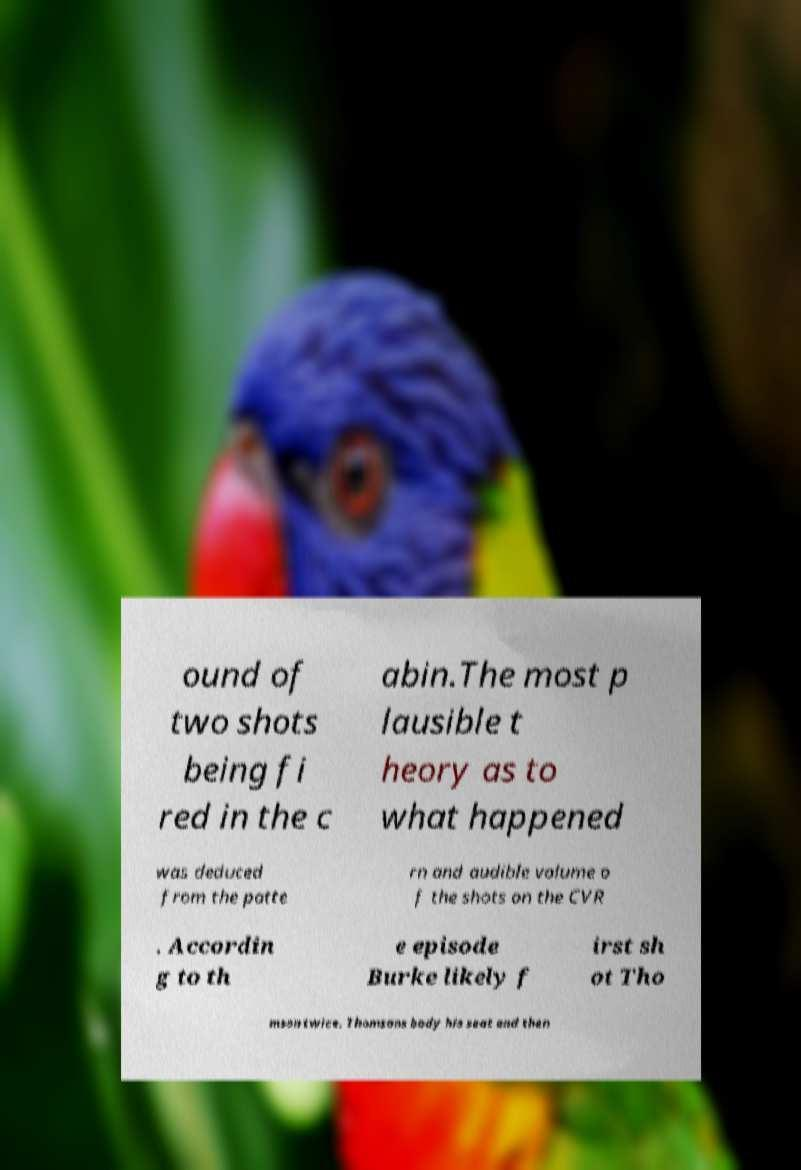I need the written content from this picture converted into text. Can you do that? ound of two shots being fi red in the c abin.The most p lausible t heory as to what happened was deduced from the patte rn and audible volume o f the shots on the CVR . Accordin g to th e episode Burke likely f irst sh ot Tho mson twice. Thomsons body his seat and then 